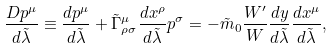<formula> <loc_0><loc_0><loc_500><loc_500>\frac { D p ^ { \mu } } { d \tilde { \lambda } } \equiv \frac { d p ^ { \mu } } { d \tilde { \lambda } } + \tilde { \Gamma } _ { \rho \sigma } ^ { \mu } \frac { d x ^ { \rho } } { d \tilde { \lambda } } p ^ { \sigma } = - \tilde { m } _ { 0 } \frac { W ^ { \prime } } { W } \frac { d y } { d \tilde { \lambda } } \frac { d x ^ { \mu } } { d \tilde { \lambda } } ,</formula> 